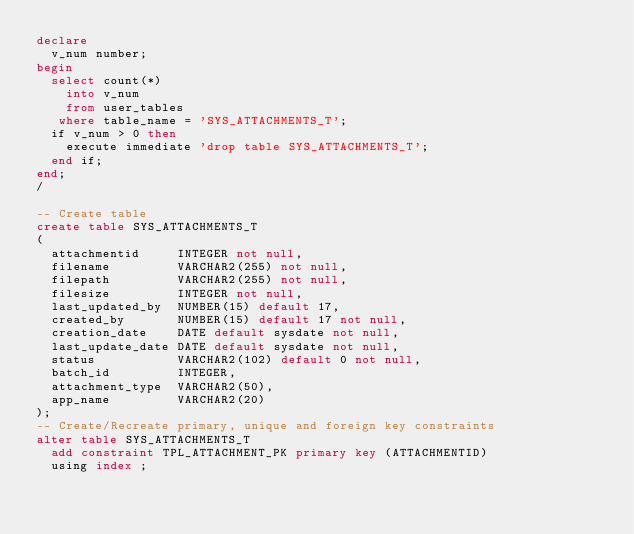Convert code to text. <code><loc_0><loc_0><loc_500><loc_500><_SQL_>declare
  v_num number;
begin
  select count(*)
    into v_num
    from user_tables
   where table_name = 'SYS_ATTACHMENTS_T';
  if v_num > 0 then
    execute immediate 'drop table SYS_ATTACHMENTS_T';
  end if;
end;
/

-- Create table
create table SYS_ATTACHMENTS_T
(
  attachmentid     INTEGER not null,
  filename         VARCHAR2(255) not null,
  filepath         VARCHAR2(255) not null,
  filesize         INTEGER not null,
  last_updated_by  NUMBER(15) default 17,
  created_by       NUMBER(15) default 17 not null,
  creation_date    DATE default sysdate not null,
  last_update_date DATE default sysdate not null,
  status           VARCHAR2(102) default 0 not null,
  batch_id         INTEGER,
  attachment_type  VARCHAR2(50),
  app_name         VARCHAR2(20)
);
-- Create/Recreate primary, unique and foreign key constraints 
alter table SYS_ATTACHMENTS_T
  add constraint TPL_ATTACHMENT_PK primary key (ATTACHMENTID)
  using index ;
</code> 